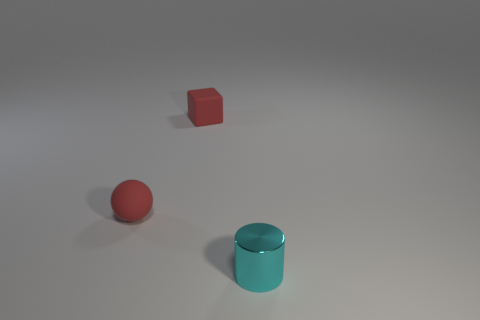How many other tiny matte things have the same shape as the tiny cyan object?
Give a very brief answer. 0. What number of objects are either small things behind the cyan cylinder or cyan metallic cylinders right of the tiny red rubber sphere?
Provide a short and direct response. 3. What material is the small thing that is in front of the red matte object in front of the tiny red matte thing that is behind the rubber sphere?
Your answer should be compact. Metal. Does the small rubber thing that is behind the red matte ball have the same color as the tiny matte ball?
Offer a terse response. Yes. The object that is on the right side of the small red matte sphere and in front of the tiny matte cube is made of what material?
Provide a short and direct response. Metal. Are there any cyan metallic things that have the same size as the sphere?
Offer a terse response. Yes. What number of big red cylinders are there?
Your response must be concise. 0. What number of small red balls are left of the small cyan metallic cylinder?
Offer a very short reply. 1. Are the tiny cube and the cylinder made of the same material?
Offer a very short reply. No. What number of small things are right of the small cube and left of the metallic object?
Ensure brevity in your answer.  0. 